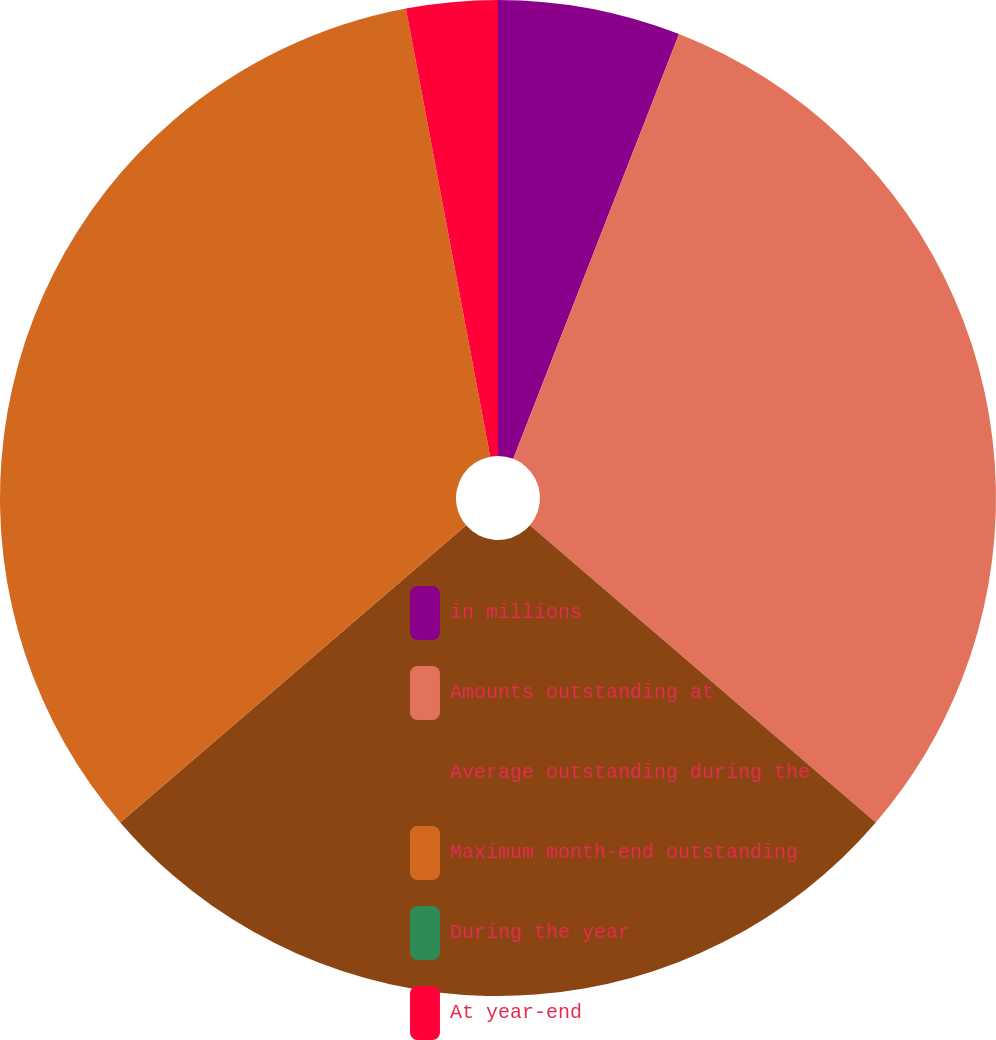Convert chart. <chart><loc_0><loc_0><loc_500><loc_500><pie_chart><fcel>in millions<fcel>Amounts outstanding at<fcel>Average outstanding during the<fcel>Maximum month-end outstanding<fcel>During the year<fcel>At year-end<nl><fcel>5.92%<fcel>30.37%<fcel>27.41%<fcel>33.33%<fcel>0.0%<fcel>2.96%<nl></chart> 